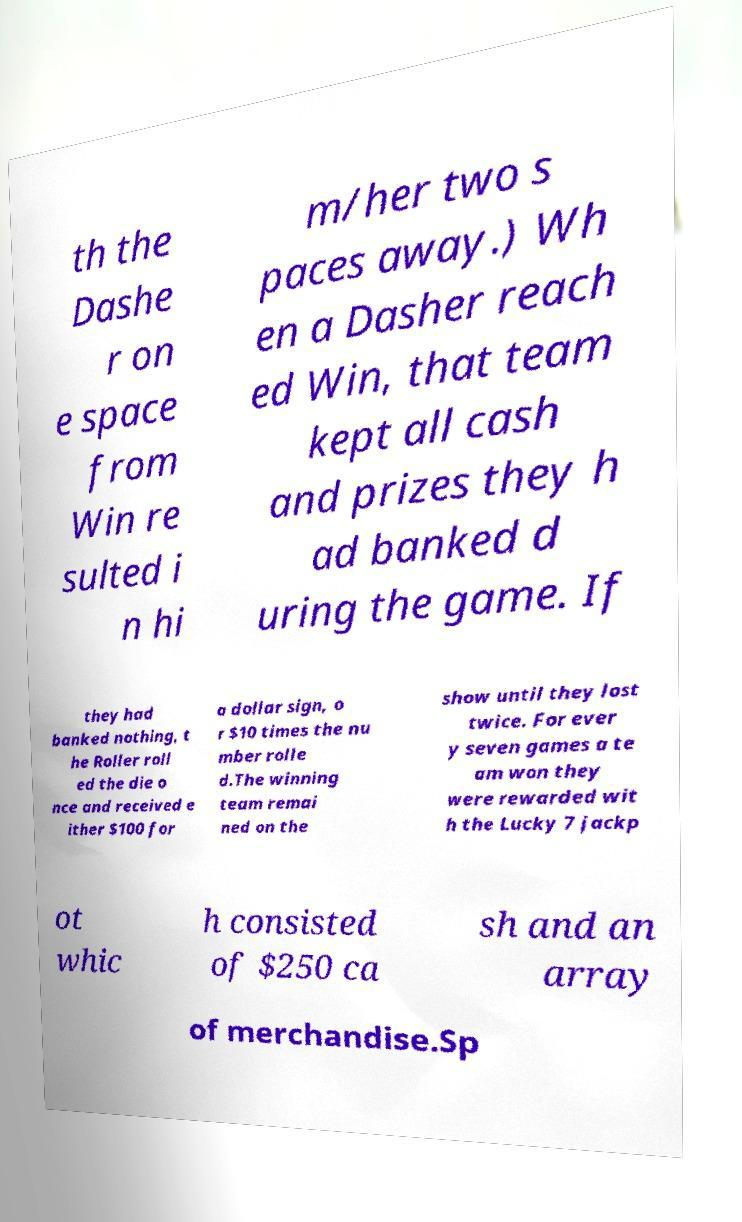Can you accurately transcribe the text from the provided image for me? th the Dashe r on e space from Win re sulted i n hi m/her two s paces away.) Wh en a Dasher reach ed Win, that team kept all cash and prizes they h ad banked d uring the game. If they had banked nothing, t he Roller roll ed the die o nce and received e ither $100 for a dollar sign, o r $10 times the nu mber rolle d.The winning team remai ned on the show until they lost twice. For ever y seven games a te am won they were rewarded wit h the Lucky 7 jackp ot whic h consisted of $250 ca sh and an array of merchandise.Sp 